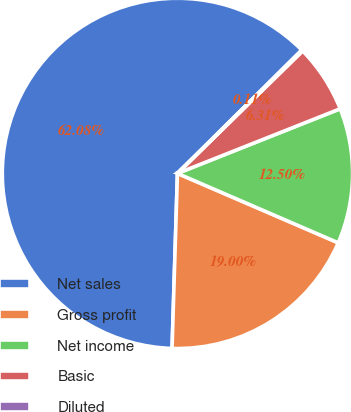<chart> <loc_0><loc_0><loc_500><loc_500><pie_chart><fcel>Net sales<fcel>Gross profit<fcel>Net income<fcel>Basic<fcel>Diluted<nl><fcel>62.07%<fcel>19.0%<fcel>12.5%<fcel>6.31%<fcel>0.11%<nl></chart> 